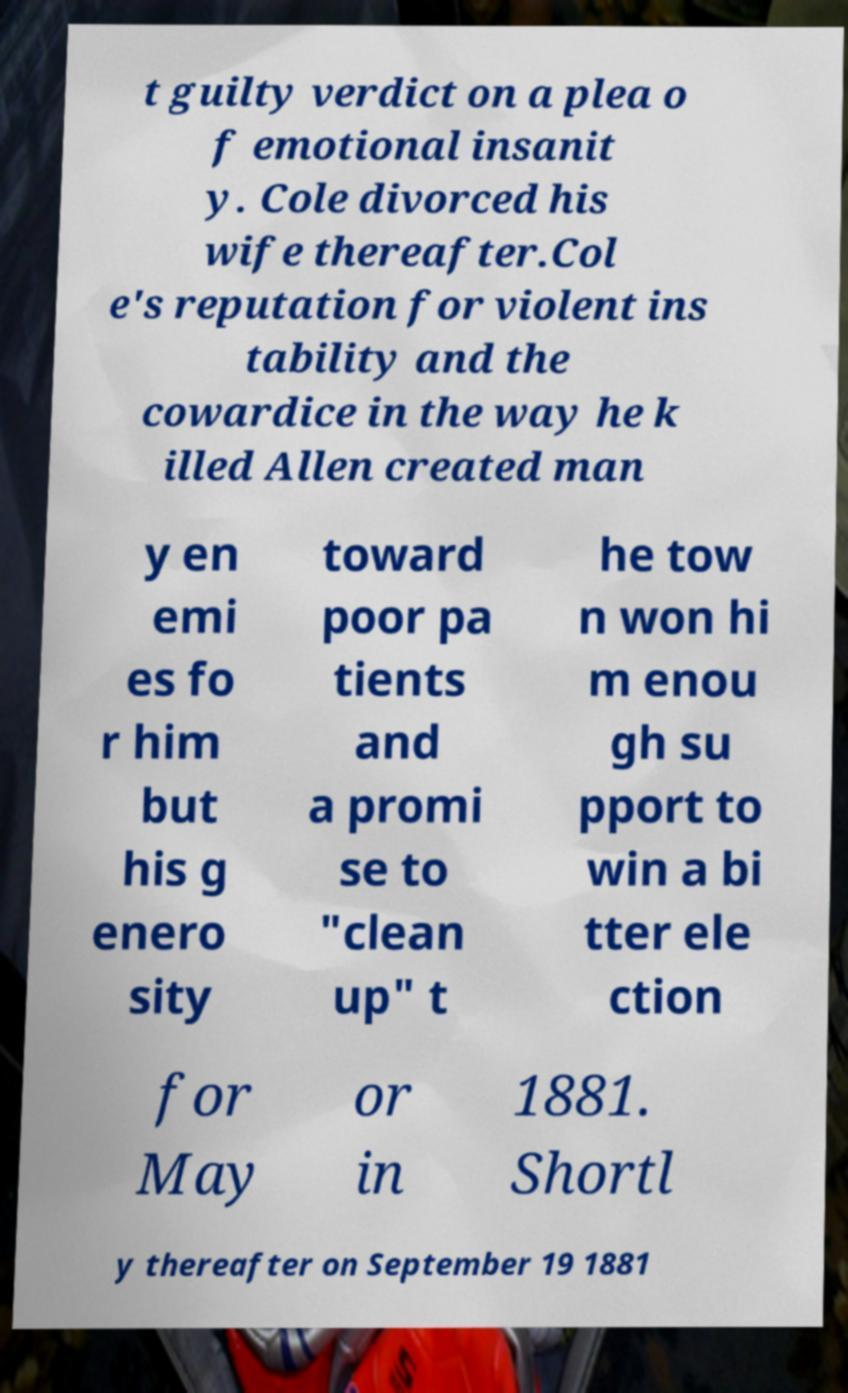For documentation purposes, I need the text within this image transcribed. Could you provide that? t guilty verdict on a plea o f emotional insanit y. Cole divorced his wife thereafter.Col e's reputation for violent ins tability and the cowardice in the way he k illed Allen created man y en emi es fo r him but his g enero sity toward poor pa tients and a promi se to "clean up" t he tow n won hi m enou gh su pport to win a bi tter ele ction for May or in 1881. Shortl y thereafter on September 19 1881 